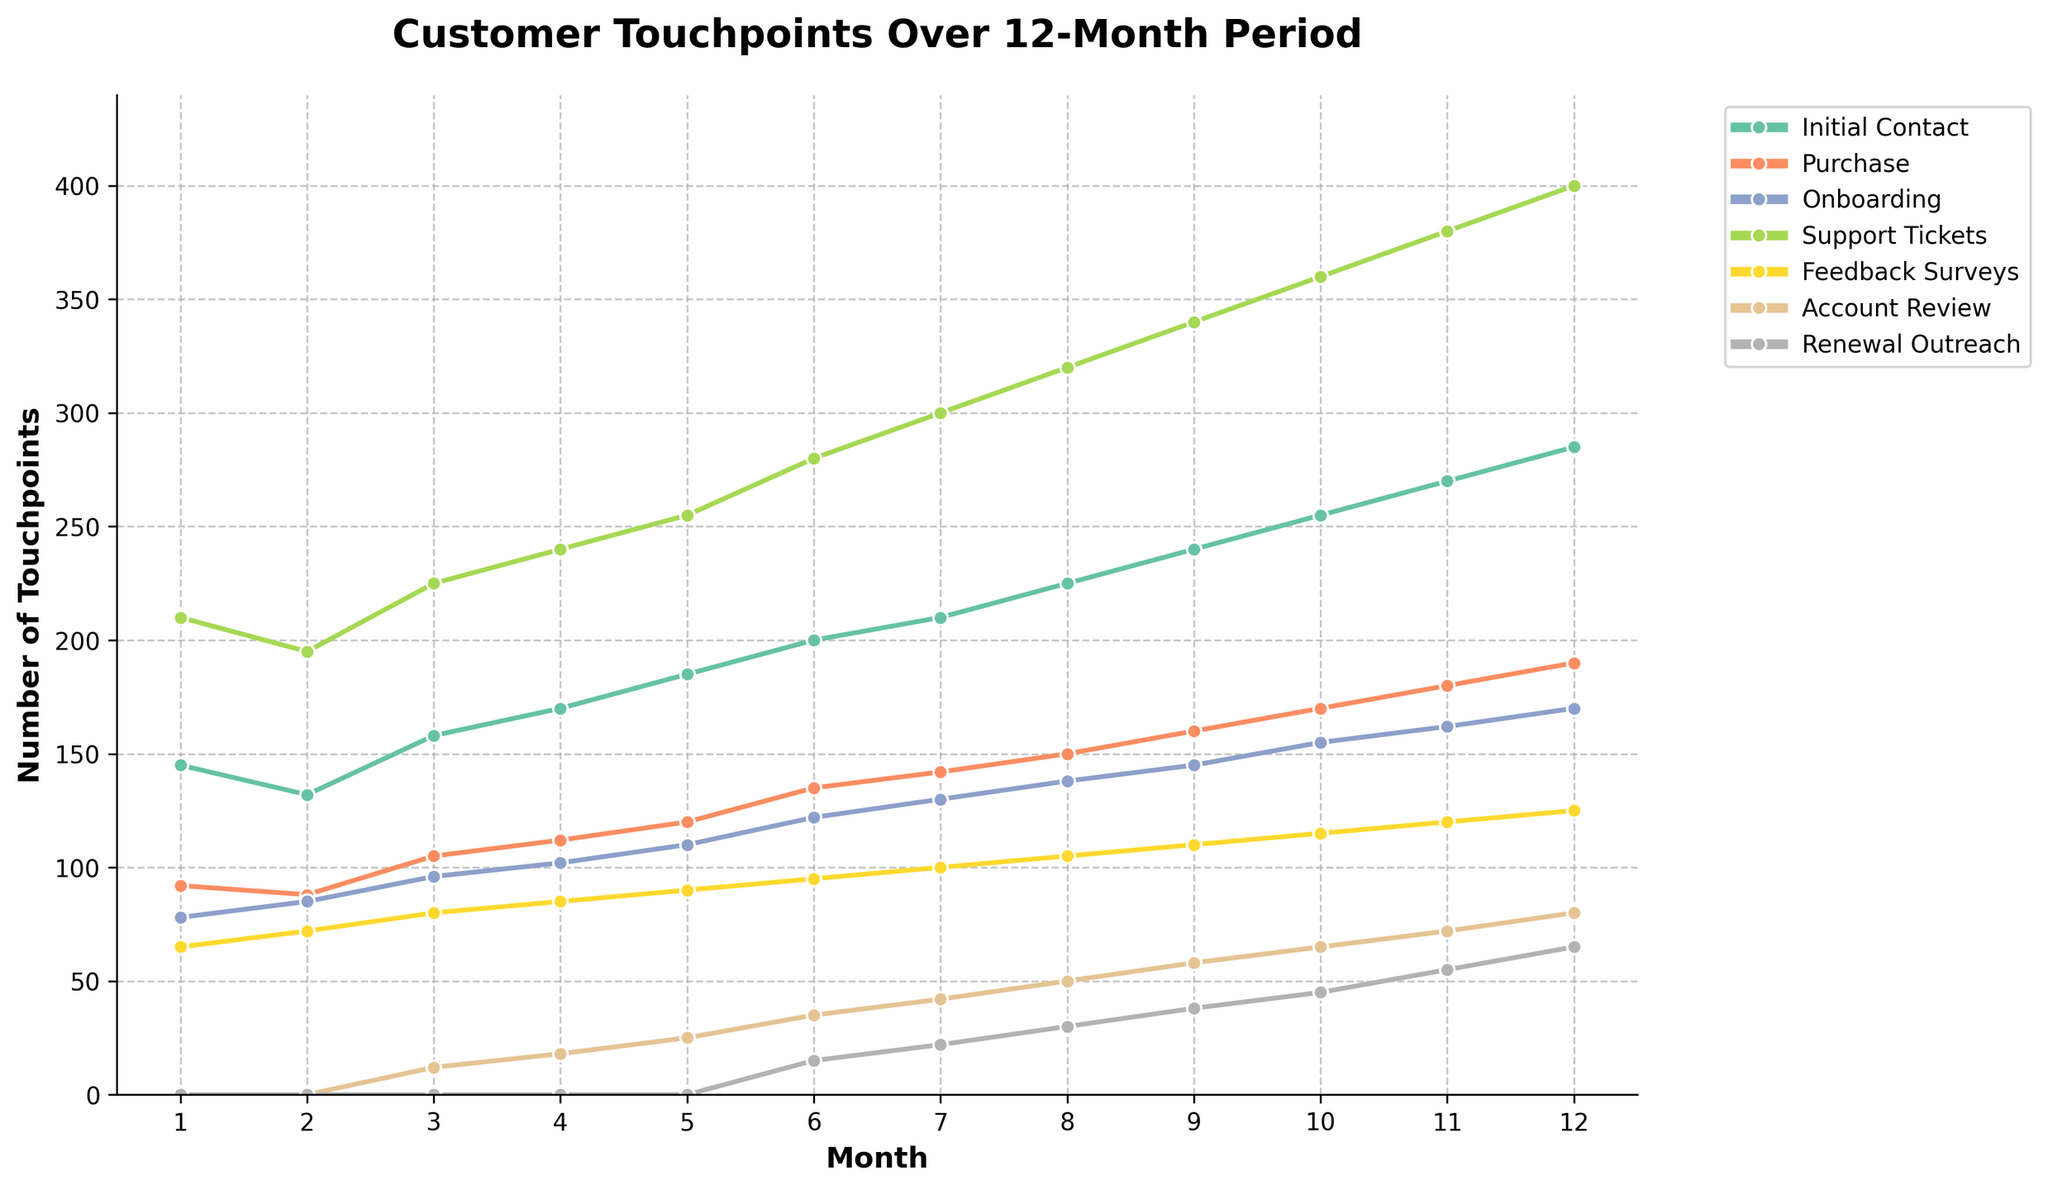What's the most frequent customer touchpoint in month 6? Look at the data for month 6 and compare the values for each touchpoint. Initial Contact has 200, Purchase has 135, Onboarding has 122, Support Tickets has 280, Feedback Surveys has 95, Account Review has 35, and Renewal Outreach has 15. Support Tickets is the highest.
Answer: Support Tickets Which month shows the highest number of purchase touchpoints and what is that number? Compare the Purchase values across all months. Month 12 has the highest Purchase touchpoints with a value of 190.
Answer: 12 and 190 What is the total number of Initial Contact touchpoints over the 12 months? Sum the Initial Contact values from each month: 145 + 132 + 158 + 170 + 185 + 200 + 210 + 225 + 240 + 255 + 270 + 285.
Answer: 2475 Which month saw the first instance of Renewal Outreach touchpoints? Scan the Renewal Outreach values and find the first non-zero value. This occurs in month 6 with a value of 15.
Answer: 6 How many more Support Tickets touchpoints were there in month 12 compared to month 1? Subtract the Support Tickets value in month 1 from that in month 12: 400 - 210.
Answer: 190 Between months 4 and 8, which saw a higher number of Onboarding touchpoints, and what is the difference? Compare the Onboarding touchpoints in month 8 and month 4: Month 4 has 102, Month 8 has 138. Difference = 138 - 102.
Answer: 8 and 36 Which touchpoint shows a consistent increase every month? Examine each touchpoint over the 12 months. All touchpoints (Initial Contact, Purchase, Onboarding, Support Tickets, Feedback Surveys, Account Review, and Renewal Outreach) exhibit a consistent increase each month.
Answer: All touchpoints What is the average number of Account Review touchpoints over the 12 months? Sum the Account Review values and divide by 12: (0 + 0 + 12 + 18 + 25 + 35 + 42 + 50 + 58 + 65 + 72 + 80) / 12.
Answer: 38.42 Between Feedback Surveys and Support Tickets, which touchpoint had a higher peak value and what is that value? Compare the peak values for Feedback Surveys (max 125) and Support Tickets (max 400). Support Tickets had a higher peak value of 400.
Answer: Support Tickets and 400 